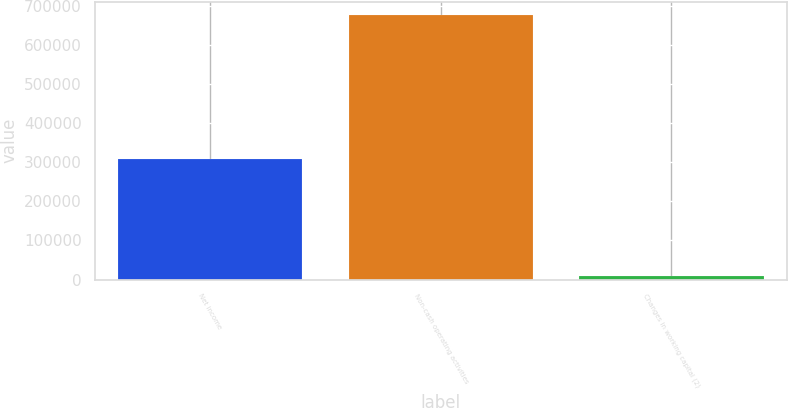Convert chart to OTSL. <chart><loc_0><loc_0><loc_500><loc_500><bar_chart><fcel>Net income<fcel>Non-cash operating activities<fcel>Changes in working capital (2)<nl><fcel>309613<fcel>677569<fcel>7905<nl></chart> 